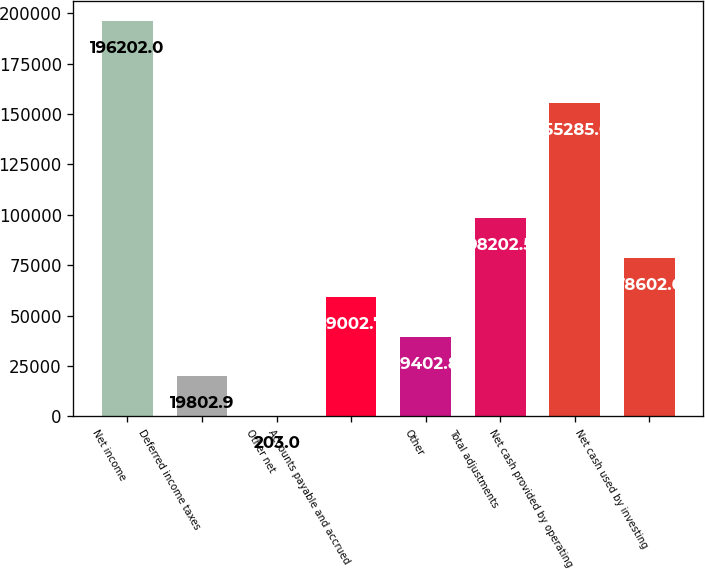Convert chart. <chart><loc_0><loc_0><loc_500><loc_500><bar_chart><fcel>Net income<fcel>Deferred income taxes<fcel>Other net<fcel>Accounts payable and accrued<fcel>Other<fcel>Total adjustments<fcel>Net cash provided by operating<fcel>Net cash used by investing<nl><fcel>196202<fcel>19802.9<fcel>203<fcel>59002.7<fcel>39402.8<fcel>98202.5<fcel>155285<fcel>78602.6<nl></chart> 